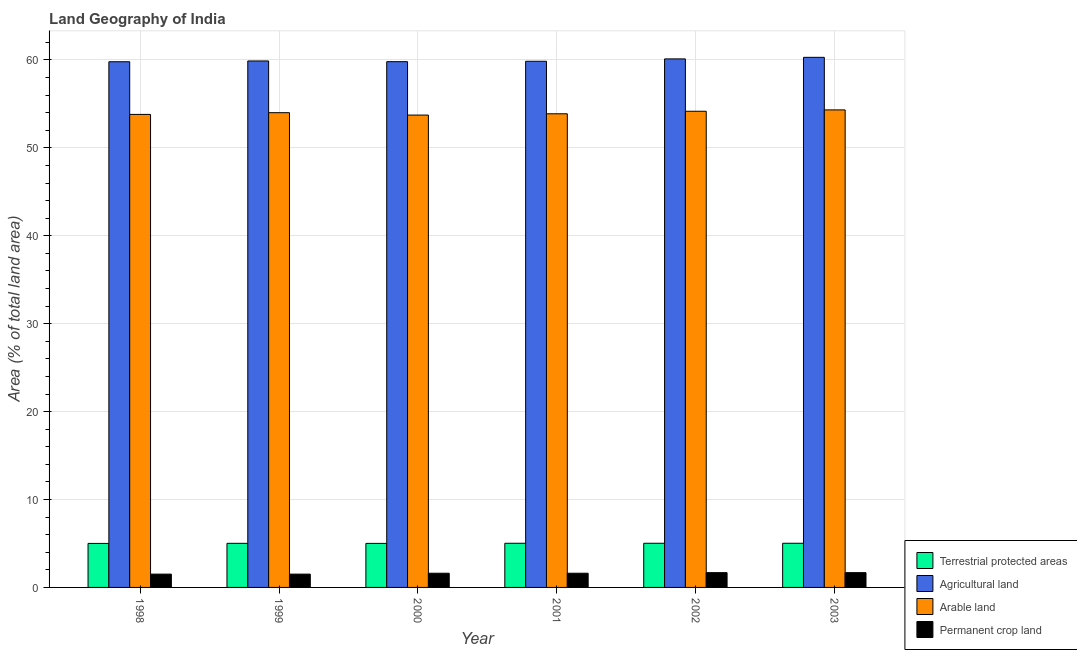Are the number of bars on each tick of the X-axis equal?
Provide a succinct answer. Yes. How many bars are there on the 5th tick from the left?
Provide a succinct answer. 4. How many bars are there on the 6th tick from the right?
Your answer should be very brief. 4. What is the label of the 4th group of bars from the left?
Offer a terse response. 2001. What is the percentage of area under arable land in 2001?
Provide a succinct answer. 53.88. Across all years, what is the maximum percentage of area under agricultural land?
Your answer should be compact. 60.3. Across all years, what is the minimum percentage of area under agricultural land?
Your response must be concise. 59.8. In which year was the percentage of area under permanent crop land maximum?
Your answer should be very brief. 2002. In which year was the percentage of land under terrestrial protection minimum?
Make the answer very short. 1998. What is the total percentage of area under arable land in the graph?
Provide a short and direct response. 323.9. What is the difference between the percentage of land under terrestrial protection in 2001 and that in 2003?
Your answer should be very brief. -1.699860379567042e-6. What is the difference between the percentage of land under terrestrial protection in 2002 and the percentage of area under permanent crop land in 2001?
Offer a terse response. 1.699860379567042e-6. What is the average percentage of land under terrestrial protection per year?
Ensure brevity in your answer.  5.02. In how many years, is the percentage of area under arable land greater than 24 %?
Your answer should be very brief. 6. What is the ratio of the percentage of area under arable land in 1999 to that in 2001?
Offer a terse response. 1. Is the percentage of area under permanent crop land in 1998 less than that in 2001?
Keep it short and to the point. Yes. What is the difference between the highest and the second highest percentage of area under agricultural land?
Your answer should be compact. 0.18. What is the difference between the highest and the lowest percentage of area under arable land?
Provide a succinct answer. 0.59. What does the 1st bar from the left in 2003 represents?
Keep it short and to the point. Terrestrial protected areas. What does the 1st bar from the right in 2000 represents?
Your answer should be very brief. Permanent crop land. Are all the bars in the graph horizontal?
Offer a very short reply. No. Are the values on the major ticks of Y-axis written in scientific E-notation?
Offer a very short reply. No. Does the graph contain any zero values?
Ensure brevity in your answer.  No. Does the graph contain grids?
Ensure brevity in your answer.  Yes. Where does the legend appear in the graph?
Provide a short and direct response. Bottom right. How many legend labels are there?
Give a very brief answer. 4. What is the title of the graph?
Provide a short and direct response. Land Geography of India. Does "Agricultural land" appear as one of the legend labels in the graph?
Offer a very short reply. Yes. What is the label or title of the Y-axis?
Your answer should be compact. Area (% of total land area). What is the Area (% of total land area) of Terrestrial protected areas in 1998?
Your answer should be compact. 5.01. What is the Area (% of total land area) of Agricultural land in 1998?
Keep it short and to the point. 59.8. What is the Area (% of total land area) of Arable land in 1998?
Offer a very short reply. 53.81. What is the Area (% of total land area) of Permanent crop land in 1998?
Keep it short and to the point. 1.51. What is the Area (% of total land area) in Terrestrial protected areas in 1999?
Provide a short and direct response. 5.02. What is the Area (% of total land area) in Agricultural land in 1999?
Your response must be concise. 59.89. What is the Area (% of total land area) in Arable land in 1999?
Offer a terse response. 54. What is the Area (% of total land area) in Permanent crop land in 1999?
Offer a terse response. 1.51. What is the Area (% of total land area) of Terrestrial protected areas in 2000?
Ensure brevity in your answer.  5.01. What is the Area (% of total land area) in Agricultural land in 2000?
Offer a terse response. 59.81. What is the Area (% of total land area) of Arable land in 2000?
Keep it short and to the point. 53.73. What is the Area (% of total land area) of Permanent crop land in 2000?
Provide a short and direct response. 1.61. What is the Area (% of total land area) in Terrestrial protected areas in 2001?
Give a very brief answer. 5.03. What is the Area (% of total land area) of Agricultural land in 2001?
Make the answer very short. 59.85. What is the Area (% of total land area) of Arable land in 2001?
Keep it short and to the point. 53.88. What is the Area (% of total land area) of Permanent crop land in 2001?
Provide a succinct answer. 1.61. What is the Area (% of total land area) of Terrestrial protected areas in 2002?
Provide a succinct answer. 5.03. What is the Area (% of total land area) of Agricultural land in 2002?
Provide a succinct answer. 60.12. What is the Area (% of total land area) of Arable land in 2002?
Offer a very short reply. 54.17. What is the Area (% of total land area) of Permanent crop land in 2002?
Provide a short and direct response. 1.68. What is the Area (% of total land area) of Terrestrial protected areas in 2003?
Give a very brief answer. 5.03. What is the Area (% of total land area) in Agricultural land in 2003?
Make the answer very short. 60.3. What is the Area (% of total land area) in Arable land in 2003?
Ensure brevity in your answer.  54.32. What is the Area (% of total land area) in Permanent crop land in 2003?
Your answer should be very brief. 1.68. Across all years, what is the maximum Area (% of total land area) of Terrestrial protected areas?
Your answer should be compact. 5.03. Across all years, what is the maximum Area (% of total land area) of Agricultural land?
Provide a short and direct response. 60.3. Across all years, what is the maximum Area (% of total land area) in Arable land?
Make the answer very short. 54.32. Across all years, what is the maximum Area (% of total land area) of Permanent crop land?
Offer a very short reply. 1.68. Across all years, what is the minimum Area (% of total land area) in Terrestrial protected areas?
Provide a short and direct response. 5.01. Across all years, what is the minimum Area (% of total land area) of Agricultural land?
Give a very brief answer. 59.8. Across all years, what is the minimum Area (% of total land area) of Arable land?
Give a very brief answer. 53.73. Across all years, what is the minimum Area (% of total land area) in Permanent crop land?
Your answer should be compact. 1.51. What is the total Area (% of total land area) of Terrestrial protected areas in the graph?
Your answer should be very brief. 30.11. What is the total Area (% of total land area) of Agricultural land in the graph?
Your answer should be compact. 359.76. What is the total Area (% of total land area) in Arable land in the graph?
Offer a terse response. 323.9. What is the total Area (% of total land area) of Permanent crop land in the graph?
Make the answer very short. 9.62. What is the difference between the Area (% of total land area) in Terrestrial protected areas in 1998 and that in 1999?
Give a very brief answer. -0.01. What is the difference between the Area (% of total land area) of Agricultural land in 1998 and that in 1999?
Your answer should be compact. -0.09. What is the difference between the Area (% of total land area) in Arable land in 1998 and that in 1999?
Your answer should be very brief. -0.2. What is the difference between the Area (% of total land area) of Permanent crop land in 1998 and that in 1999?
Your response must be concise. 0. What is the difference between the Area (% of total land area) of Terrestrial protected areas in 1998 and that in 2000?
Make the answer very short. -0. What is the difference between the Area (% of total land area) in Agricultural land in 1998 and that in 2000?
Give a very brief answer. -0.01. What is the difference between the Area (% of total land area) in Arable land in 1998 and that in 2000?
Your answer should be compact. 0.07. What is the difference between the Area (% of total land area) of Permanent crop land in 1998 and that in 2000?
Provide a succinct answer. -0.1. What is the difference between the Area (% of total land area) of Terrestrial protected areas in 1998 and that in 2001?
Your response must be concise. -0.02. What is the difference between the Area (% of total land area) in Agricultural land in 1998 and that in 2001?
Offer a very short reply. -0.05. What is the difference between the Area (% of total land area) in Arable land in 1998 and that in 2001?
Provide a short and direct response. -0.07. What is the difference between the Area (% of total land area) of Permanent crop land in 1998 and that in 2001?
Give a very brief answer. -0.1. What is the difference between the Area (% of total land area) of Terrestrial protected areas in 1998 and that in 2002?
Keep it short and to the point. -0.02. What is the difference between the Area (% of total land area) in Agricultural land in 1998 and that in 2002?
Your answer should be compact. -0.32. What is the difference between the Area (% of total land area) in Arable land in 1998 and that in 2002?
Provide a short and direct response. -0.36. What is the difference between the Area (% of total land area) in Permanent crop land in 1998 and that in 2002?
Your response must be concise. -0.17. What is the difference between the Area (% of total land area) in Terrestrial protected areas in 1998 and that in 2003?
Provide a succinct answer. -0.02. What is the difference between the Area (% of total land area) of Agricultural land in 1998 and that in 2003?
Your answer should be very brief. -0.5. What is the difference between the Area (% of total land area) in Arable land in 1998 and that in 2003?
Offer a very short reply. -0.51. What is the difference between the Area (% of total land area) of Permanent crop land in 1998 and that in 2003?
Your answer should be very brief. -0.17. What is the difference between the Area (% of total land area) of Terrestrial protected areas in 1999 and that in 2000?
Provide a succinct answer. 0.01. What is the difference between the Area (% of total land area) in Agricultural land in 1999 and that in 2000?
Ensure brevity in your answer.  0.08. What is the difference between the Area (% of total land area) of Arable land in 1999 and that in 2000?
Keep it short and to the point. 0.27. What is the difference between the Area (% of total land area) in Permanent crop land in 1999 and that in 2000?
Keep it short and to the point. -0.1. What is the difference between the Area (% of total land area) in Terrestrial protected areas in 1999 and that in 2001?
Provide a short and direct response. -0.01. What is the difference between the Area (% of total land area) in Agricultural land in 1999 and that in 2001?
Your answer should be compact. 0.04. What is the difference between the Area (% of total land area) in Arable land in 1999 and that in 2001?
Provide a short and direct response. 0.13. What is the difference between the Area (% of total land area) in Permanent crop land in 1999 and that in 2001?
Give a very brief answer. -0.1. What is the difference between the Area (% of total land area) of Terrestrial protected areas in 1999 and that in 2002?
Ensure brevity in your answer.  -0.01. What is the difference between the Area (% of total land area) of Agricultural land in 1999 and that in 2002?
Make the answer very short. -0.24. What is the difference between the Area (% of total land area) in Arable land in 1999 and that in 2002?
Ensure brevity in your answer.  -0.16. What is the difference between the Area (% of total land area) in Permanent crop land in 1999 and that in 2002?
Your response must be concise. -0.17. What is the difference between the Area (% of total land area) in Terrestrial protected areas in 1999 and that in 2003?
Keep it short and to the point. -0.01. What is the difference between the Area (% of total land area) of Agricultural land in 1999 and that in 2003?
Offer a terse response. -0.41. What is the difference between the Area (% of total land area) of Arable land in 1999 and that in 2003?
Ensure brevity in your answer.  -0.32. What is the difference between the Area (% of total land area) in Permanent crop land in 1999 and that in 2003?
Provide a short and direct response. -0.17. What is the difference between the Area (% of total land area) in Terrestrial protected areas in 2000 and that in 2001?
Provide a succinct answer. -0.01. What is the difference between the Area (% of total land area) in Agricultural land in 2000 and that in 2001?
Make the answer very short. -0.04. What is the difference between the Area (% of total land area) in Arable land in 2000 and that in 2001?
Your answer should be very brief. -0.14. What is the difference between the Area (% of total land area) in Terrestrial protected areas in 2000 and that in 2002?
Offer a terse response. -0.01. What is the difference between the Area (% of total land area) of Agricultural land in 2000 and that in 2002?
Provide a succinct answer. -0.31. What is the difference between the Area (% of total land area) of Arable land in 2000 and that in 2002?
Provide a succinct answer. -0.43. What is the difference between the Area (% of total land area) in Permanent crop land in 2000 and that in 2002?
Provide a short and direct response. -0.07. What is the difference between the Area (% of total land area) in Terrestrial protected areas in 2000 and that in 2003?
Keep it short and to the point. -0.01. What is the difference between the Area (% of total land area) in Agricultural land in 2000 and that in 2003?
Ensure brevity in your answer.  -0.49. What is the difference between the Area (% of total land area) in Arable land in 2000 and that in 2003?
Offer a terse response. -0.59. What is the difference between the Area (% of total land area) of Permanent crop land in 2000 and that in 2003?
Ensure brevity in your answer.  -0.07. What is the difference between the Area (% of total land area) of Terrestrial protected areas in 2001 and that in 2002?
Your answer should be compact. -0. What is the difference between the Area (% of total land area) in Agricultural land in 2001 and that in 2002?
Give a very brief answer. -0.27. What is the difference between the Area (% of total land area) of Arable land in 2001 and that in 2002?
Offer a terse response. -0.29. What is the difference between the Area (% of total land area) in Permanent crop land in 2001 and that in 2002?
Your response must be concise. -0.07. What is the difference between the Area (% of total land area) in Terrestrial protected areas in 2001 and that in 2003?
Provide a succinct answer. -0. What is the difference between the Area (% of total land area) of Agricultural land in 2001 and that in 2003?
Provide a succinct answer. -0.45. What is the difference between the Area (% of total land area) in Arable land in 2001 and that in 2003?
Provide a short and direct response. -0.44. What is the difference between the Area (% of total land area) in Permanent crop land in 2001 and that in 2003?
Your answer should be very brief. -0.07. What is the difference between the Area (% of total land area) in Terrestrial protected areas in 2002 and that in 2003?
Provide a short and direct response. 0. What is the difference between the Area (% of total land area) of Agricultural land in 2002 and that in 2003?
Offer a very short reply. -0.18. What is the difference between the Area (% of total land area) in Arable land in 2002 and that in 2003?
Provide a succinct answer. -0.15. What is the difference between the Area (% of total land area) in Terrestrial protected areas in 1998 and the Area (% of total land area) in Agricultural land in 1999?
Make the answer very short. -54.88. What is the difference between the Area (% of total land area) of Terrestrial protected areas in 1998 and the Area (% of total land area) of Arable land in 1999?
Ensure brevity in your answer.  -49. What is the difference between the Area (% of total land area) in Terrestrial protected areas in 1998 and the Area (% of total land area) in Permanent crop land in 1999?
Offer a very short reply. 3.49. What is the difference between the Area (% of total land area) in Agricultural land in 1998 and the Area (% of total land area) in Arable land in 1999?
Provide a succinct answer. 5.8. What is the difference between the Area (% of total land area) in Agricultural land in 1998 and the Area (% of total land area) in Permanent crop land in 1999?
Offer a terse response. 58.28. What is the difference between the Area (% of total land area) in Arable land in 1998 and the Area (% of total land area) in Permanent crop land in 1999?
Provide a succinct answer. 52.29. What is the difference between the Area (% of total land area) of Terrestrial protected areas in 1998 and the Area (% of total land area) of Agricultural land in 2000?
Provide a succinct answer. -54.8. What is the difference between the Area (% of total land area) of Terrestrial protected areas in 1998 and the Area (% of total land area) of Arable land in 2000?
Keep it short and to the point. -48.73. What is the difference between the Area (% of total land area) in Terrestrial protected areas in 1998 and the Area (% of total land area) in Permanent crop land in 2000?
Ensure brevity in your answer.  3.39. What is the difference between the Area (% of total land area) in Agricultural land in 1998 and the Area (% of total land area) in Arable land in 2000?
Provide a succinct answer. 6.07. What is the difference between the Area (% of total land area) in Agricultural land in 1998 and the Area (% of total land area) in Permanent crop land in 2000?
Make the answer very short. 58.18. What is the difference between the Area (% of total land area) of Arable land in 1998 and the Area (% of total land area) of Permanent crop land in 2000?
Keep it short and to the point. 52.19. What is the difference between the Area (% of total land area) of Terrestrial protected areas in 1998 and the Area (% of total land area) of Agricultural land in 2001?
Offer a terse response. -54.84. What is the difference between the Area (% of total land area) of Terrestrial protected areas in 1998 and the Area (% of total land area) of Arable land in 2001?
Ensure brevity in your answer.  -48.87. What is the difference between the Area (% of total land area) in Terrestrial protected areas in 1998 and the Area (% of total land area) in Permanent crop land in 2001?
Your answer should be very brief. 3.39. What is the difference between the Area (% of total land area) of Agricultural land in 1998 and the Area (% of total land area) of Arable land in 2001?
Your answer should be very brief. 5.92. What is the difference between the Area (% of total land area) of Agricultural land in 1998 and the Area (% of total land area) of Permanent crop land in 2001?
Your response must be concise. 58.18. What is the difference between the Area (% of total land area) of Arable land in 1998 and the Area (% of total land area) of Permanent crop land in 2001?
Your answer should be very brief. 52.19. What is the difference between the Area (% of total land area) in Terrestrial protected areas in 1998 and the Area (% of total land area) in Agricultural land in 2002?
Offer a very short reply. -55.11. What is the difference between the Area (% of total land area) of Terrestrial protected areas in 1998 and the Area (% of total land area) of Arable land in 2002?
Make the answer very short. -49.16. What is the difference between the Area (% of total land area) in Terrestrial protected areas in 1998 and the Area (% of total land area) in Permanent crop land in 2002?
Make the answer very short. 3.32. What is the difference between the Area (% of total land area) of Agricultural land in 1998 and the Area (% of total land area) of Arable land in 2002?
Offer a very short reply. 5.63. What is the difference between the Area (% of total land area) in Agricultural land in 1998 and the Area (% of total land area) in Permanent crop land in 2002?
Keep it short and to the point. 58.12. What is the difference between the Area (% of total land area) in Arable land in 1998 and the Area (% of total land area) in Permanent crop land in 2002?
Offer a terse response. 52.12. What is the difference between the Area (% of total land area) in Terrestrial protected areas in 1998 and the Area (% of total land area) in Agricultural land in 2003?
Your answer should be very brief. -55.29. What is the difference between the Area (% of total land area) of Terrestrial protected areas in 1998 and the Area (% of total land area) of Arable land in 2003?
Offer a terse response. -49.31. What is the difference between the Area (% of total land area) of Terrestrial protected areas in 1998 and the Area (% of total land area) of Permanent crop land in 2003?
Your response must be concise. 3.32. What is the difference between the Area (% of total land area) of Agricultural land in 1998 and the Area (% of total land area) of Arable land in 2003?
Your answer should be compact. 5.48. What is the difference between the Area (% of total land area) of Agricultural land in 1998 and the Area (% of total land area) of Permanent crop land in 2003?
Your answer should be very brief. 58.12. What is the difference between the Area (% of total land area) of Arable land in 1998 and the Area (% of total land area) of Permanent crop land in 2003?
Your response must be concise. 52.12. What is the difference between the Area (% of total land area) in Terrestrial protected areas in 1999 and the Area (% of total land area) in Agricultural land in 2000?
Offer a very short reply. -54.79. What is the difference between the Area (% of total land area) of Terrestrial protected areas in 1999 and the Area (% of total land area) of Arable land in 2000?
Offer a terse response. -48.71. What is the difference between the Area (% of total land area) in Terrestrial protected areas in 1999 and the Area (% of total land area) in Permanent crop land in 2000?
Keep it short and to the point. 3.4. What is the difference between the Area (% of total land area) in Agricultural land in 1999 and the Area (% of total land area) in Arable land in 2000?
Make the answer very short. 6.15. What is the difference between the Area (% of total land area) of Agricultural land in 1999 and the Area (% of total land area) of Permanent crop land in 2000?
Give a very brief answer. 58.27. What is the difference between the Area (% of total land area) of Arable land in 1999 and the Area (% of total land area) of Permanent crop land in 2000?
Offer a very short reply. 52.39. What is the difference between the Area (% of total land area) of Terrestrial protected areas in 1999 and the Area (% of total land area) of Agricultural land in 2001?
Keep it short and to the point. -54.83. What is the difference between the Area (% of total land area) of Terrestrial protected areas in 1999 and the Area (% of total land area) of Arable land in 2001?
Keep it short and to the point. -48.86. What is the difference between the Area (% of total land area) of Terrestrial protected areas in 1999 and the Area (% of total land area) of Permanent crop land in 2001?
Make the answer very short. 3.4. What is the difference between the Area (% of total land area) of Agricultural land in 1999 and the Area (% of total land area) of Arable land in 2001?
Your answer should be compact. 6.01. What is the difference between the Area (% of total land area) in Agricultural land in 1999 and the Area (% of total land area) in Permanent crop land in 2001?
Your answer should be very brief. 58.27. What is the difference between the Area (% of total land area) of Arable land in 1999 and the Area (% of total land area) of Permanent crop land in 2001?
Your answer should be very brief. 52.39. What is the difference between the Area (% of total land area) of Terrestrial protected areas in 1999 and the Area (% of total land area) of Agricultural land in 2002?
Offer a terse response. -55.1. What is the difference between the Area (% of total land area) of Terrestrial protected areas in 1999 and the Area (% of total land area) of Arable land in 2002?
Make the answer very short. -49.15. What is the difference between the Area (% of total land area) in Terrestrial protected areas in 1999 and the Area (% of total land area) in Permanent crop land in 2002?
Give a very brief answer. 3.34. What is the difference between the Area (% of total land area) of Agricultural land in 1999 and the Area (% of total land area) of Arable land in 2002?
Offer a very short reply. 5.72. What is the difference between the Area (% of total land area) in Agricultural land in 1999 and the Area (% of total land area) in Permanent crop land in 2002?
Offer a very short reply. 58.2. What is the difference between the Area (% of total land area) in Arable land in 1999 and the Area (% of total land area) in Permanent crop land in 2002?
Keep it short and to the point. 52.32. What is the difference between the Area (% of total land area) of Terrestrial protected areas in 1999 and the Area (% of total land area) of Agricultural land in 2003?
Offer a terse response. -55.28. What is the difference between the Area (% of total land area) of Terrestrial protected areas in 1999 and the Area (% of total land area) of Arable land in 2003?
Keep it short and to the point. -49.3. What is the difference between the Area (% of total land area) in Terrestrial protected areas in 1999 and the Area (% of total land area) in Permanent crop land in 2003?
Keep it short and to the point. 3.34. What is the difference between the Area (% of total land area) of Agricultural land in 1999 and the Area (% of total land area) of Arable land in 2003?
Your answer should be compact. 5.57. What is the difference between the Area (% of total land area) in Agricultural land in 1999 and the Area (% of total land area) in Permanent crop land in 2003?
Make the answer very short. 58.2. What is the difference between the Area (% of total land area) in Arable land in 1999 and the Area (% of total land area) in Permanent crop land in 2003?
Your answer should be very brief. 52.32. What is the difference between the Area (% of total land area) of Terrestrial protected areas in 2000 and the Area (% of total land area) of Agricultural land in 2001?
Give a very brief answer. -54.84. What is the difference between the Area (% of total land area) in Terrestrial protected areas in 2000 and the Area (% of total land area) in Arable land in 2001?
Give a very brief answer. -48.87. What is the difference between the Area (% of total land area) in Terrestrial protected areas in 2000 and the Area (% of total land area) in Permanent crop land in 2001?
Your response must be concise. 3.4. What is the difference between the Area (% of total land area) in Agricultural land in 2000 and the Area (% of total land area) in Arable land in 2001?
Offer a very short reply. 5.93. What is the difference between the Area (% of total land area) of Agricultural land in 2000 and the Area (% of total land area) of Permanent crop land in 2001?
Give a very brief answer. 58.19. What is the difference between the Area (% of total land area) of Arable land in 2000 and the Area (% of total land area) of Permanent crop land in 2001?
Provide a short and direct response. 52.12. What is the difference between the Area (% of total land area) in Terrestrial protected areas in 2000 and the Area (% of total land area) in Agricultural land in 2002?
Make the answer very short. -55.11. What is the difference between the Area (% of total land area) of Terrestrial protected areas in 2000 and the Area (% of total land area) of Arable land in 2002?
Give a very brief answer. -49.15. What is the difference between the Area (% of total land area) in Terrestrial protected areas in 2000 and the Area (% of total land area) in Permanent crop land in 2002?
Provide a succinct answer. 3.33. What is the difference between the Area (% of total land area) of Agricultural land in 2000 and the Area (% of total land area) of Arable land in 2002?
Offer a very short reply. 5.64. What is the difference between the Area (% of total land area) of Agricultural land in 2000 and the Area (% of total land area) of Permanent crop land in 2002?
Make the answer very short. 58.13. What is the difference between the Area (% of total land area) of Arable land in 2000 and the Area (% of total land area) of Permanent crop land in 2002?
Provide a succinct answer. 52.05. What is the difference between the Area (% of total land area) in Terrestrial protected areas in 2000 and the Area (% of total land area) in Agricultural land in 2003?
Keep it short and to the point. -55.29. What is the difference between the Area (% of total land area) in Terrestrial protected areas in 2000 and the Area (% of total land area) in Arable land in 2003?
Provide a succinct answer. -49.31. What is the difference between the Area (% of total land area) of Terrestrial protected areas in 2000 and the Area (% of total land area) of Permanent crop land in 2003?
Your response must be concise. 3.33. What is the difference between the Area (% of total land area) of Agricultural land in 2000 and the Area (% of total land area) of Arable land in 2003?
Your response must be concise. 5.49. What is the difference between the Area (% of total land area) in Agricultural land in 2000 and the Area (% of total land area) in Permanent crop land in 2003?
Your answer should be compact. 58.13. What is the difference between the Area (% of total land area) in Arable land in 2000 and the Area (% of total land area) in Permanent crop land in 2003?
Offer a terse response. 52.05. What is the difference between the Area (% of total land area) of Terrestrial protected areas in 2001 and the Area (% of total land area) of Agricultural land in 2002?
Make the answer very short. -55.1. What is the difference between the Area (% of total land area) of Terrestrial protected areas in 2001 and the Area (% of total land area) of Arable land in 2002?
Your answer should be compact. -49.14. What is the difference between the Area (% of total land area) in Terrestrial protected areas in 2001 and the Area (% of total land area) in Permanent crop land in 2002?
Offer a terse response. 3.34. What is the difference between the Area (% of total land area) of Agricultural land in 2001 and the Area (% of total land area) of Arable land in 2002?
Make the answer very short. 5.68. What is the difference between the Area (% of total land area) of Agricultural land in 2001 and the Area (% of total land area) of Permanent crop land in 2002?
Provide a short and direct response. 58.17. What is the difference between the Area (% of total land area) of Arable land in 2001 and the Area (% of total land area) of Permanent crop land in 2002?
Keep it short and to the point. 52.2. What is the difference between the Area (% of total land area) of Terrestrial protected areas in 2001 and the Area (% of total land area) of Agricultural land in 2003?
Provide a succinct answer. -55.27. What is the difference between the Area (% of total land area) in Terrestrial protected areas in 2001 and the Area (% of total land area) in Arable land in 2003?
Provide a short and direct response. -49.29. What is the difference between the Area (% of total land area) in Terrestrial protected areas in 2001 and the Area (% of total land area) in Permanent crop land in 2003?
Offer a very short reply. 3.34. What is the difference between the Area (% of total land area) in Agricultural land in 2001 and the Area (% of total land area) in Arable land in 2003?
Offer a terse response. 5.53. What is the difference between the Area (% of total land area) in Agricultural land in 2001 and the Area (% of total land area) in Permanent crop land in 2003?
Provide a succinct answer. 58.17. What is the difference between the Area (% of total land area) of Arable land in 2001 and the Area (% of total land area) of Permanent crop land in 2003?
Provide a short and direct response. 52.2. What is the difference between the Area (% of total land area) of Terrestrial protected areas in 2002 and the Area (% of total land area) of Agricultural land in 2003?
Make the answer very short. -55.27. What is the difference between the Area (% of total land area) in Terrestrial protected areas in 2002 and the Area (% of total land area) in Arable land in 2003?
Your answer should be compact. -49.29. What is the difference between the Area (% of total land area) of Terrestrial protected areas in 2002 and the Area (% of total land area) of Permanent crop land in 2003?
Offer a very short reply. 3.34. What is the difference between the Area (% of total land area) in Agricultural land in 2002 and the Area (% of total land area) in Arable land in 2003?
Ensure brevity in your answer.  5.8. What is the difference between the Area (% of total land area) of Agricultural land in 2002 and the Area (% of total land area) of Permanent crop land in 2003?
Give a very brief answer. 58.44. What is the difference between the Area (% of total land area) in Arable land in 2002 and the Area (% of total land area) in Permanent crop land in 2003?
Ensure brevity in your answer.  52.48. What is the average Area (% of total land area) in Terrestrial protected areas per year?
Make the answer very short. 5.02. What is the average Area (% of total land area) in Agricultural land per year?
Provide a short and direct response. 59.96. What is the average Area (% of total land area) in Arable land per year?
Your answer should be very brief. 53.98. What is the average Area (% of total land area) of Permanent crop land per year?
Your response must be concise. 1.6. In the year 1998, what is the difference between the Area (% of total land area) in Terrestrial protected areas and Area (% of total land area) in Agricultural land?
Provide a succinct answer. -54.79. In the year 1998, what is the difference between the Area (% of total land area) of Terrestrial protected areas and Area (% of total land area) of Arable land?
Your answer should be very brief. -48.8. In the year 1998, what is the difference between the Area (% of total land area) in Terrestrial protected areas and Area (% of total land area) in Permanent crop land?
Your response must be concise. 3.49. In the year 1998, what is the difference between the Area (% of total land area) of Agricultural land and Area (% of total land area) of Arable land?
Provide a short and direct response. 5.99. In the year 1998, what is the difference between the Area (% of total land area) of Agricultural land and Area (% of total land area) of Permanent crop land?
Offer a terse response. 58.28. In the year 1998, what is the difference between the Area (% of total land area) in Arable land and Area (% of total land area) in Permanent crop land?
Give a very brief answer. 52.29. In the year 1999, what is the difference between the Area (% of total land area) in Terrestrial protected areas and Area (% of total land area) in Agricultural land?
Ensure brevity in your answer.  -54.87. In the year 1999, what is the difference between the Area (% of total land area) of Terrestrial protected areas and Area (% of total land area) of Arable land?
Make the answer very short. -48.99. In the year 1999, what is the difference between the Area (% of total land area) of Terrestrial protected areas and Area (% of total land area) of Permanent crop land?
Provide a short and direct response. 3.5. In the year 1999, what is the difference between the Area (% of total land area) of Agricultural land and Area (% of total land area) of Arable land?
Ensure brevity in your answer.  5.88. In the year 1999, what is the difference between the Area (% of total land area) of Agricultural land and Area (% of total land area) of Permanent crop land?
Make the answer very short. 58.37. In the year 1999, what is the difference between the Area (% of total land area) in Arable land and Area (% of total land area) in Permanent crop land?
Give a very brief answer. 52.49. In the year 2000, what is the difference between the Area (% of total land area) of Terrestrial protected areas and Area (% of total land area) of Agricultural land?
Ensure brevity in your answer.  -54.8. In the year 2000, what is the difference between the Area (% of total land area) of Terrestrial protected areas and Area (% of total land area) of Arable land?
Make the answer very short. -48.72. In the year 2000, what is the difference between the Area (% of total land area) of Terrestrial protected areas and Area (% of total land area) of Permanent crop land?
Keep it short and to the point. 3.4. In the year 2000, what is the difference between the Area (% of total land area) in Agricultural land and Area (% of total land area) in Arable land?
Your answer should be compact. 6.07. In the year 2000, what is the difference between the Area (% of total land area) of Agricultural land and Area (% of total land area) of Permanent crop land?
Provide a short and direct response. 58.19. In the year 2000, what is the difference between the Area (% of total land area) in Arable land and Area (% of total land area) in Permanent crop land?
Provide a short and direct response. 52.12. In the year 2001, what is the difference between the Area (% of total land area) of Terrestrial protected areas and Area (% of total land area) of Agricultural land?
Your answer should be compact. -54.83. In the year 2001, what is the difference between the Area (% of total land area) of Terrestrial protected areas and Area (% of total land area) of Arable land?
Your answer should be very brief. -48.85. In the year 2001, what is the difference between the Area (% of total land area) of Terrestrial protected areas and Area (% of total land area) of Permanent crop land?
Give a very brief answer. 3.41. In the year 2001, what is the difference between the Area (% of total land area) in Agricultural land and Area (% of total land area) in Arable land?
Keep it short and to the point. 5.97. In the year 2001, what is the difference between the Area (% of total land area) of Agricultural land and Area (% of total land area) of Permanent crop land?
Ensure brevity in your answer.  58.24. In the year 2001, what is the difference between the Area (% of total land area) in Arable land and Area (% of total land area) in Permanent crop land?
Give a very brief answer. 52.26. In the year 2002, what is the difference between the Area (% of total land area) in Terrestrial protected areas and Area (% of total land area) in Agricultural land?
Provide a short and direct response. -55.1. In the year 2002, what is the difference between the Area (% of total land area) in Terrestrial protected areas and Area (% of total land area) in Arable land?
Give a very brief answer. -49.14. In the year 2002, what is the difference between the Area (% of total land area) of Terrestrial protected areas and Area (% of total land area) of Permanent crop land?
Offer a very short reply. 3.34. In the year 2002, what is the difference between the Area (% of total land area) in Agricultural land and Area (% of total land area) in Arable land?
Keep it short and to the point. 5.96. In the year 2002, what is the difference between the Area (% of total land area) of Agricultural land and Area (% of total land area) of Permanent crop land?
Make the answer very short. 58.44. In the year 2002, what is the difference between the Area (% of total land area) in Arable land and Area (% of total land area) in Permanent crop land?
Provide a succinct answer. 52.48. In the year 2003, what is the difference between the Area (% of total land area) of Terrestrial protected areas and Area (% of total land area) of Agricultural land?
Make the answer very short. -55.27. In the year 2003, what is the difference between the Area (% of total land area) in Terrestrial protected areas and Area (% of total land area) in Arable land?
Ensure brevity in your answer.  -49.29. In the year 2003, what is the difference between the Area (% of total land area) of Terrestrial protected areas and Area (% of total land area) of Permanent crop land?
Your answer should be very brief. 3.34. In the year 2003, what is the difference between the Area (% of total land area) in Agricultural land and Area (% of total land area) in Arable land?
Ensure brevity in your answer.  5.98. In the year 2003, what is the difference between the Area (% of total land area) of Agricultural land and Area (% of total land area) of Permanent crop land?
Offer a very short reply. 58.62. In the year 2003, what is the difference between the Area (% of total land area) in Arable land and Area (% of total land area) in Permanent crop land?
Provide a short and direct response. 52.64. What is the ratio of the Area (% of total land area) in Arable land in 1998 to that in 1999?
Your response must be concise. 1. What is the ratio of the Area (% of total land area) of Permanent crop land in 1998 to that in 1999?
Provide a short and direct response. 1. What is the ratio of the Area (% of total land area) of Arable land in 1998 to that in 2000?
Offer a terse response. 1. What is the ratio of the Area (% of total land area) of Terrestrial protected areas in 1998 to that in 2001?
Provide a succinct answer. 1. What is the ratio of the Area (% of total land area) of Terrestrial protected areas in 1998 to that in 2002?
Provide a short and direct response. 1. What is the ratio of the Area (% of total land area) in Arable land in 1998 to that in 2002?
Your response must be concise. 0.99. What is the ratio of the Area (% of total land area) of Permanent crop land in 1998 to that in 2002?
Make the answer very short. 0.9. What is the ratio of the Area (% of total land area) in Arable land in 1998 to that in 2003?
Give a very brief answer. 0.99. What is the ratio of the Area (% of total land area) of Agricultural land in 1999 to that in 2000?
Your response must be concise. 1. What is the ratio of the Area (% of total land area) of Arable land in 1999 to that in 2000?
Your answer should be compact. 1. What is the ratio of the Area (% of total land area) in Permanent crop land in 1999 to that in 2000?
Offer a very short reply. 0.94. What is the ratio of the Area (% of total land area) in Agricultural land in 1999 to that in 2001?
Provide a succinct answer. 1. What is the ratio of the Area (% of total land area) in Arable land in 1999 to that in 2001?
Offer a terse response. 1. What is the ratio of the Area (% of total land area) of Terrestrial protected areas in 1999 to that in 2002?
Offer a terse response. 1. What is the ratio of the Area (% of total land area) in Agricultural land in 1999 to that in 2002?
Your answer should be very brief. 1. What is the ratio of the Area (% of total land area) in Arable land in 1999 to that in 2002?
Your answer should be compact. 1. What is the ratio of the Area (% of total land area) in Agricultural land in 1999 to that in 2003?
Provide a short and direct response. 0.99. What is the ratio of the Area (% of total land area) in Permanent crop land in 1999 to that in 2003?
Offer a very short reply. 0.9. What is the ratio of the Area (% of total land area) in Agricultural land in 2000 to that in 2001?
Offer a very short reply. 1. What is the ratio of the Area (% of total land area) of Terrestrial protected areas in 2000 to that in 2002?
Offer a very short reply. 1. What is the ratio of the Area (% of total land area) of Arable land in 2000 to that in 2002?
Your answer should be compact. 0.99. What is the ratio of the Area (% of total land area) in Permanent crop land in 2000 to that in 2002?
Provide a succinct answer. 0.96. What is the ratio of the Area (% of total land area) of Agricultural land in 2000 to that in 2003?
Ensure brevity in your answer.  0.99. What is the ratio of the Area (% of total land area) in Agricultural land in 2001 to that in 2002?
Offer a very short reply. 1. What is the ratio of the Area (% of total land area) of Arable land in 2001 to that in 2002?
Your answer should be compact. 0.99. What is the ratio of the Area (% of total land area) of Terrestrial protected areas in 2001 to that in 2003?
Provide a succinct answer. 1. What is the ratio of the Area (% of total land area) in Arable land in 2001 to that in 2003?
Offer a terse response. 0.99. What is the ratio of the Area (% of total land area) of Permanent crop land in 2001 to that in 2003?
Ensure brevity in your answer.  0.96. What is the ratio of the Area (% of total land area) of Arable land in 2002 to that in 2003?
Give a very brief answer. 1. What is the difference between the highest and the second highest Area (% of total land area) in Agricultural land?
Give a very brief answer. 0.18. What is the difference between the highest and the second highest Area (% of total land area) in Arable land?
Provide a succinct answer. 0.15. What is the difference between the highest and the second highest Area (% of total land area) of Permanent crop land?
Keep it short and to the point. 0. What is the difference between the highest and the lowest Area (% of total land area) of Terrestrial protected areas?
Your answer should be compact. 0.02. What is the difference between the highest and the lowest Area (% of total land area) in Agricultural land?
Provide a short and direct response. 0.5. What is the difference between the highest and the lowest Area (% of total land area) in Arable land?
Keep it short and to the point. 0.59. What is the difference between the highest and the lowest Area (% of total land area) of Permanent crop land?
Offer a terse response. 0.17. 